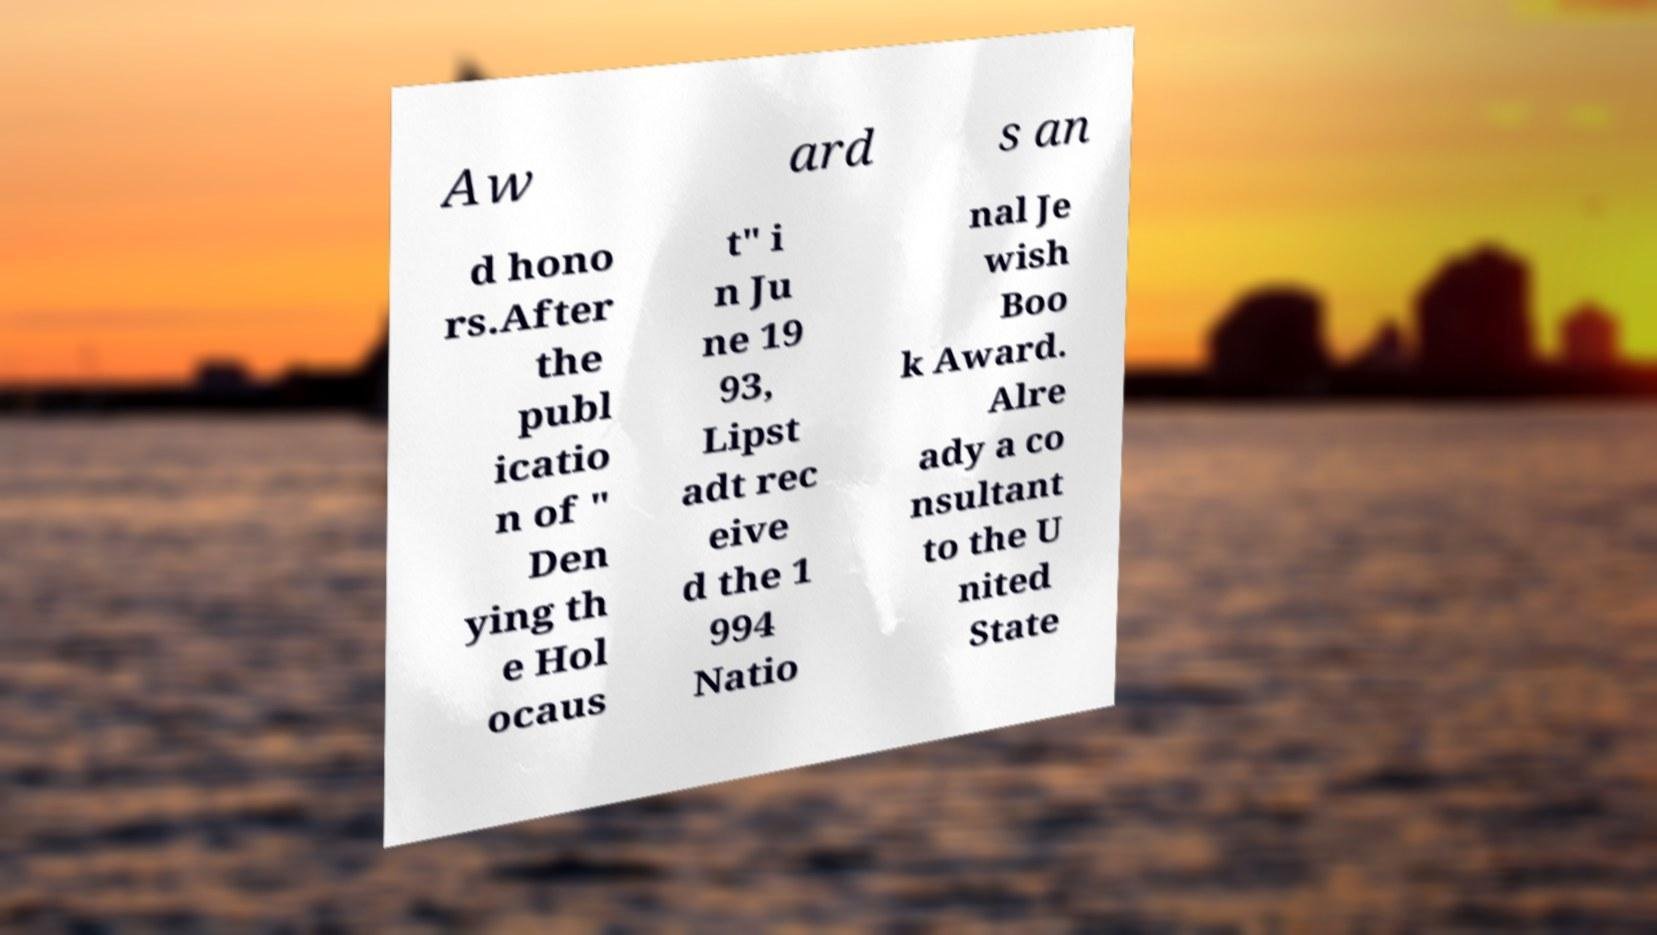There's text embedded in this image that I need extracted. Can you transcribe it verbatim? Aw ard s an d hono rs.After the publ icatio n of " Den ying th e Hol ocaus t" i n Ju ne 19 93, Lipst adt rec eive d the 1 994 Natio nal Je wish Boo k Award. Alre ady a co nsultant to the U nited State 